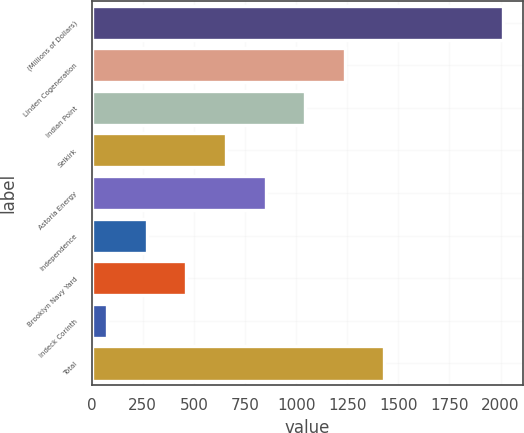<chart> <loc_0><loc_0><loc_500><loc_500><bar_chart><fcel>(Millions of Dollars)<fcel>Linden Cogeneration<fcel>Indian Point<fcel>Selkirk<fcel>Astoria Energy<fcel>Independence<fcel>Brooklyn Navy Yard<fcel>Indeck Corinth<fcel>Total<nl><fcel>2011<fcel>1237.4<fcel>1044<fcel>657.2<fcel>850.6<fcel>270.4<fcel>463.8<fcel>77<fcel>1430.8<nl></chart> 